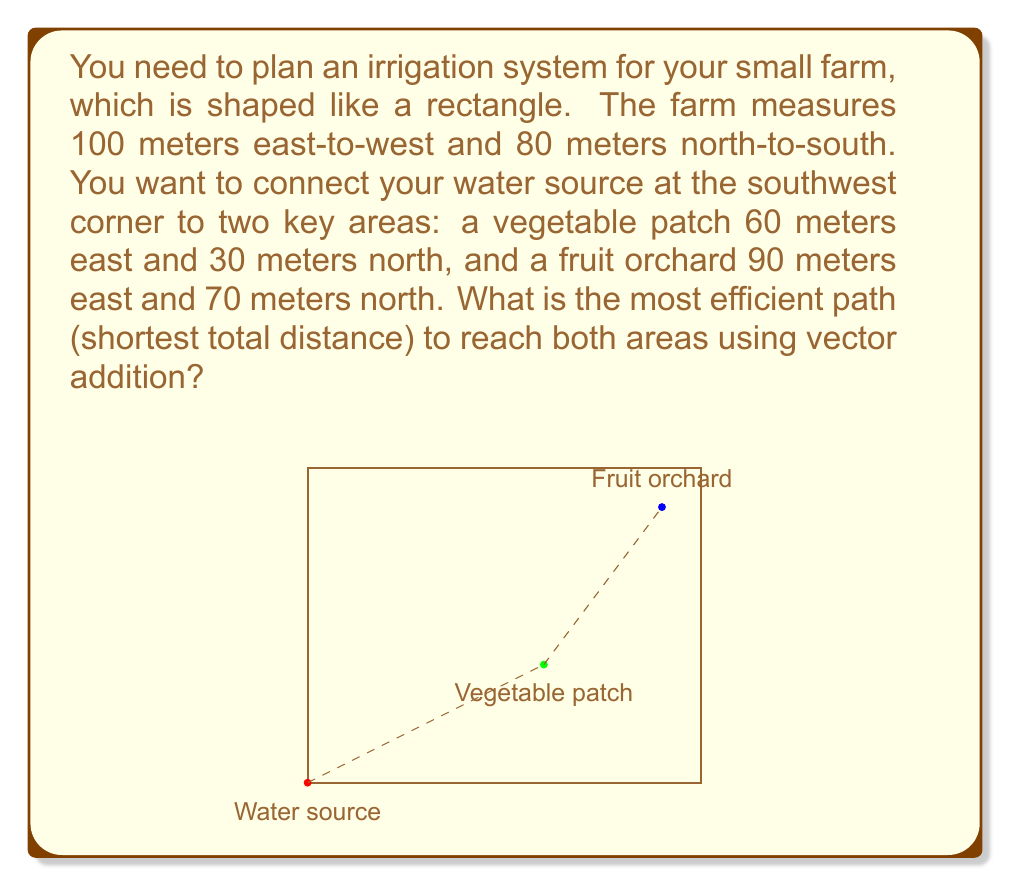Give your solution to this math problem. Let's approach this step-by-step using vector addition:

1) First, let's define our vectors:
   $\vec{a}$ = vector from water source to vegetable patch
   $\vec{b}$ = vector from vegetable patch to fruit orchard

2) We can represent these vectors as:
   $\vec{a} = 60\hat{i} + 30\hat{j}$
   $\vec{b} = (90-60)\hat{i} + (70-30)\hat{j} = 30\hat{i} + 40\hat{j}$

3) The total distance will be the magnitude of $\vec{a}$ plus the magnitude of $\vec{b}$:

   $|\vec{a}| = \sqrt{60^2 + 30^2} = \sqrt{4500} = 67.08$ meters
   $|\vec{b}| = \sqrt{30^2 + 40^2} = \sqrt{2500} = 50$ meters

4) Total distance = $|\vec{a}| + |\vec{b}| = 67.08 + 50 = 117.08$ meters

5) This path (water source → vegetable patch → fruit orchard) is the most efficient because it minimizes the total distance traveled while reaching both key areas.

6) We can verify this is shorter than going directly to the fruit orchard and then to the vegetable patch:
   Direct to fruit orchard: $\sqrt{90^2 + 70^2} = 114.02$ meters
   From fruit orchard to vegetable patch: $\sqrt{30^2 + 40^2} = 50$ meters
   Total: 114.02 + 50 = 164.02 meters (which is longer)
Answer: 117.08 meters 